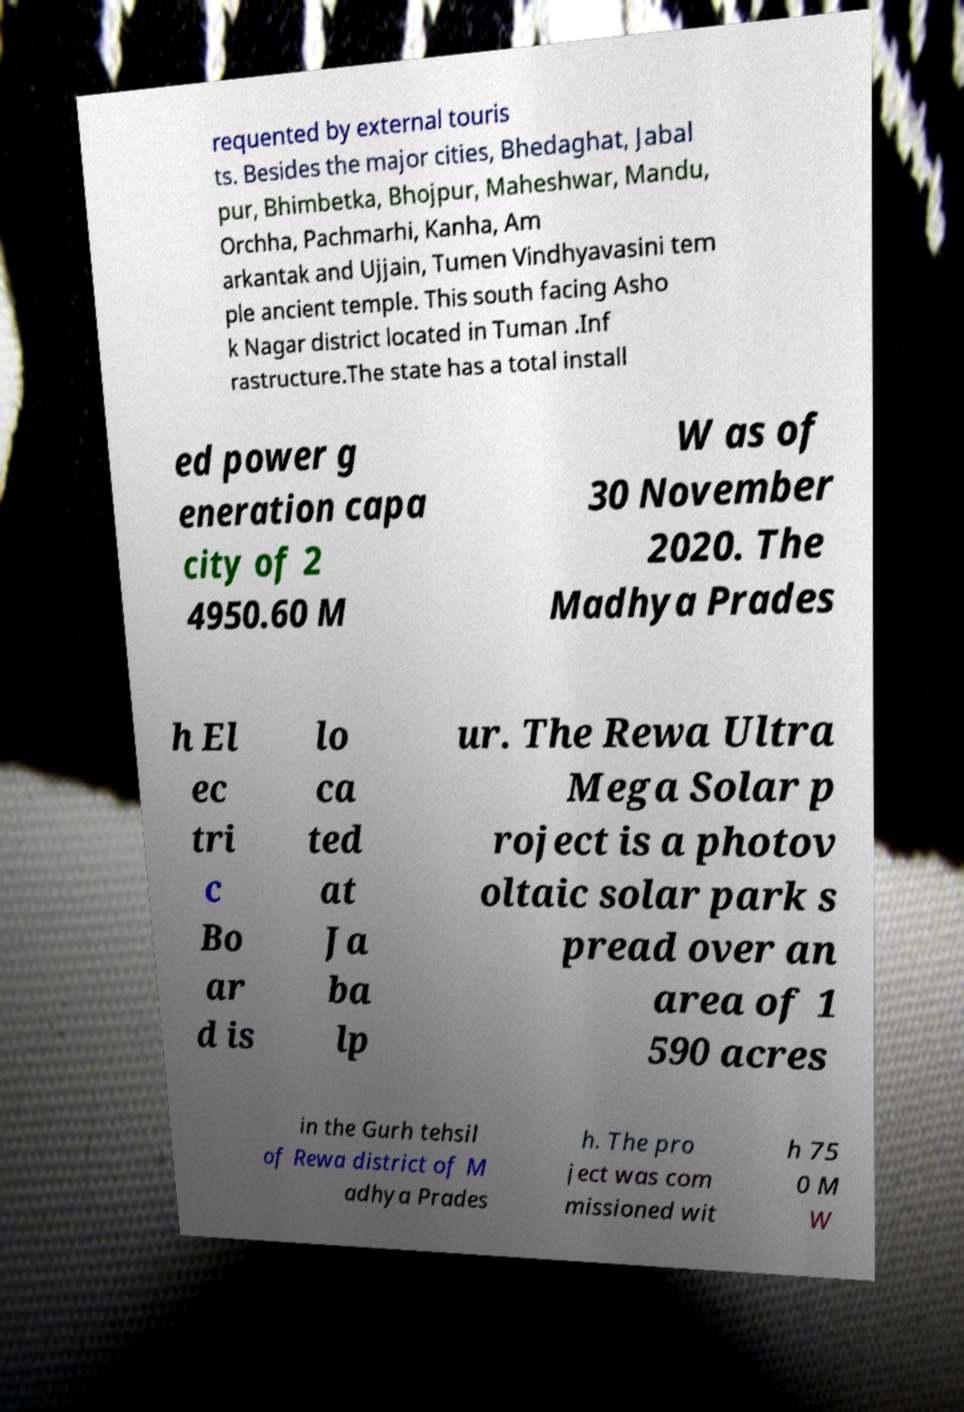Please identify and transcribe the text found in this image. requented by external touris ts. Besides the major cities, Bhedaghat, Jabal pur, Bhimbetka, Bhojpur, Maheshwar, Mandu, Orchha, Pachmarhi, Kanha, Am arkantak and Ujjain, Tumen Vindhyavasini tem ple ancient temple. This south facing Asho k Nagar district located in Tuman .Inf rastructure.The state has a total install ed power g eneration capa city of 2 4950.60 M W as of 30 November 2020. The Madhya Prades h El ec tri c Bo ar d is lo ca ted at Ja ba lp ur. The Rewa Ultra Mega Solar p roject is a photov oltaic solar park s pread over an area of 1 590 acres in the Gurh tehsil of Rewa district of M adhya Prades h. The pro ject was com missioned wit h 75 0 M W 